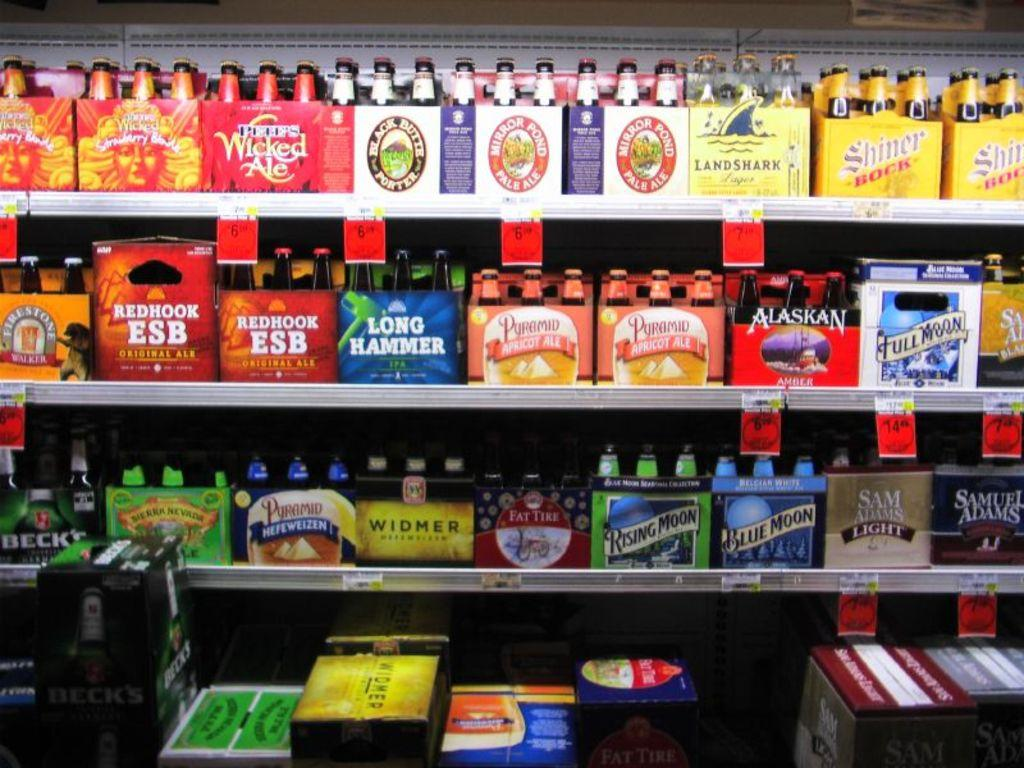<image>
Provide a brief description of the given image. A grocery shelf shows several beer cartons on shelves including Full Moon among other brands. 